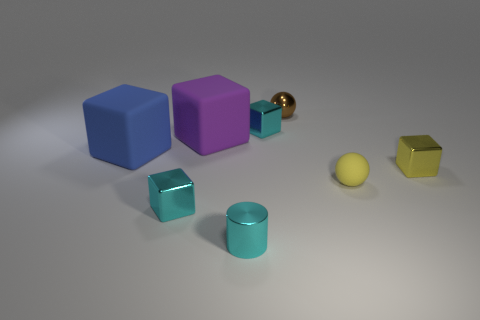How many cylinders are tiny cyan metallic objects or big objects?
Give a very brief answer. 1. The small thing that is both in front of the yellow cube and right of the small brown metal ball has what shape?
Your answer should be very brief. Sphere. Are there any blue blocks that have the same size as the metallic sphere?
Ensure brevity in your answer.  No. What number of things are small cyan cubes that are on the right side of the tiny cyan cylinder or brown objects?
Your answer should be compact. 2. Are the purple object and the big object in front of the big purple matte cube made of the same material?
Your answer should be very brief. Yes. What number of other things are there of the same shape as the large blue object?
Make the answer very short. 4. How many objects are either cubes right of the small brown thing or blocks in front of the purple matte object?
Your answer should be very brief. 3. How many other things are the same color as the small cylinder?
Your answer should be very brief. 2. Is the number of large blue matte cubes in front of the small yellow metal thing less than the number of shiny objects behind the small cylinder?
Keep it short and to the point. Yes. How many large blue rubber balls are there?
Offer a very short reply. 0. 